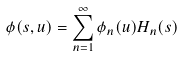Convert formula to latex. <formula><loc_0><loc_0><loc_500><loc_500>\phi ( s , u ) = \sum _ { n = 1 } ^ { \infty } \phi _ { n } ( u ) H _ { n } ( s )</formula> 